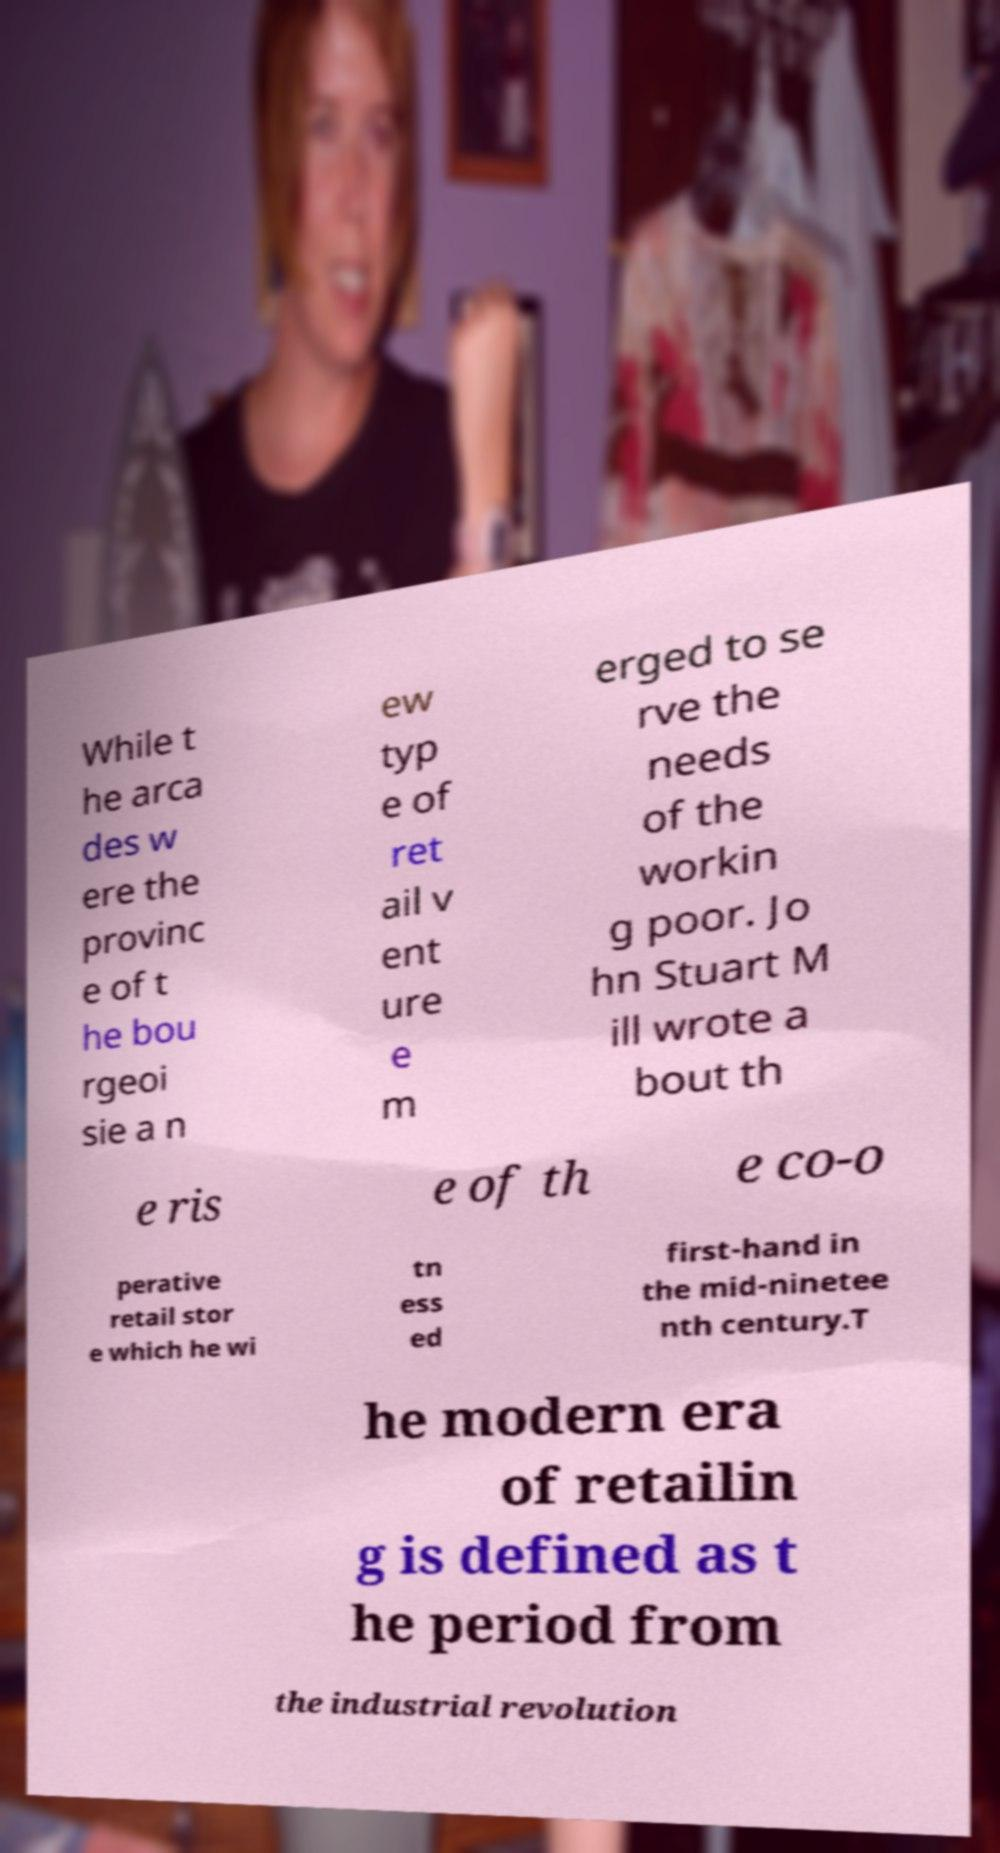Could you extract and type out the text from this image? While t he arca des w ere the provinc e of t he bou rgeoi sie a n ew typ e of ret ail v ent ure e m erged to se rve the needs of the workin g poor. Jo hn Stuart M ill wrote a bout th e ris e of th e co-o perative retail stor e which he wi tn ess ed first-hand in the mid-ninetee nth century.T he modern era of retailin g is defined as t he period from the industrial revolution 